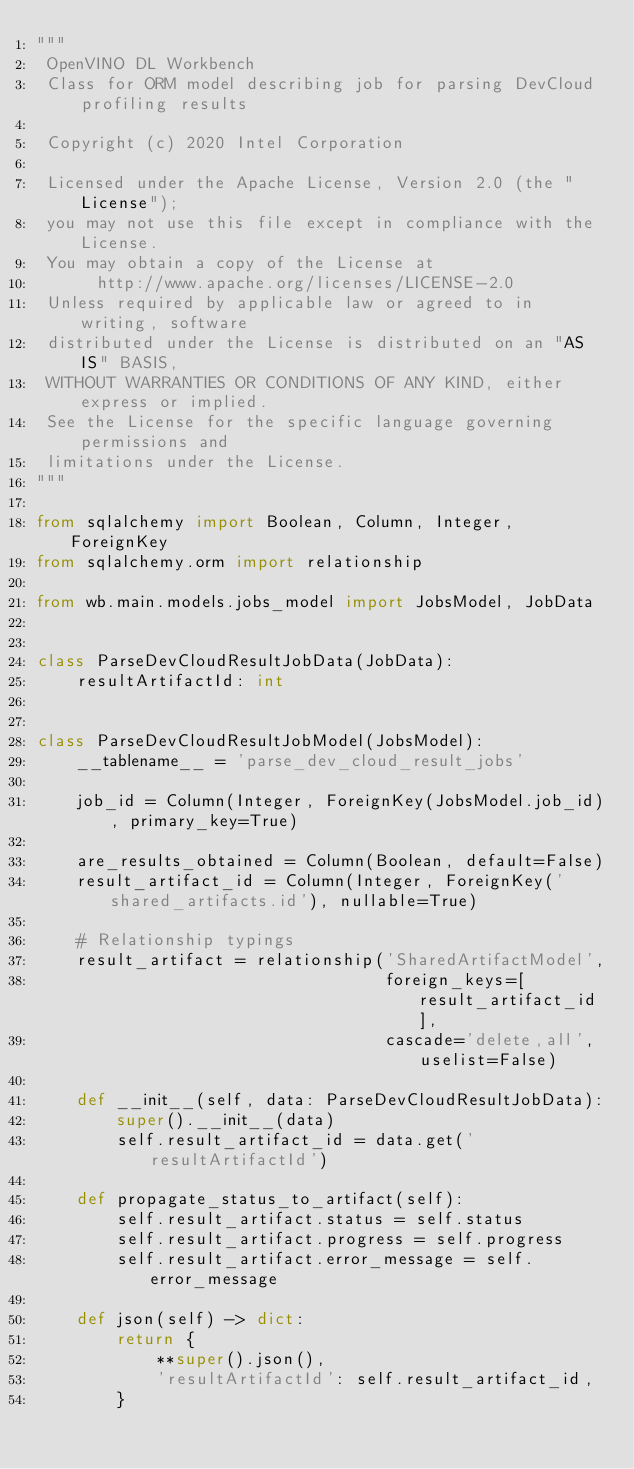Convert code to text. <code><loc_0><loc_0><loc_500><loc_500><_Python_>"""
 OpenVINO DL Workbench
 Class for ORM model describing job for parsing DevCloud profiling results

 Copyright (c) 2020 Intel Corporation

 Licensed under the Apache License, Version 2.0 (the "License");
 you may not use this file except in compliance with the License.
 You may obtain a copy of the License at
      http://www.apache.org/licenses/LICENSE-2.0
 Unless required by applicable law or agreed to in writing, software
 distributed under the License is distributed on an "AS IS" BASIS,
 WITHOUT WARRANTIES OR CONDITIONS OF ANY KIND, either express or implied.
 See the License for the specific language governing permissions and
 limitations under the License.
"""

from sqlalchemy import Boolean, Column, Integer, ForeignKey
from sqlalchemy.orm import relationship

from wb.main.models.jobs_model import JobsModel, JobData


class ParseDevCloudResultJobData(JobData):
    resultArtifactId: int


class ParseDevCloudResultJobModel(JobsModel):
    __tablename__ = 'parse_dev_cloud_result_jobs'

    job_id = Column(Integer, ForeignKey(JobsModel.job_id), primary_key=True)

    are_results_obtained = Column(Boolean, default=False)
    result_artifact_id = Column(Integer, ForeignKey('shared_artifacts.id'), nullable=True)

    # Relationship typings
    result_artifact = relationship('SharedArtifactModel',
                                   foreign_keys=[result_artifact_id],
                                   cascade='delete,all', uselist=False)

    def __init__(self, data: ParseDevCloudResultJobData):
        super().__init__(data)
        self.result_artifact_id = data.get('resultArtifactId')

    def propagate_status_to_artifact(self):
        self.result_artifact.status = self.status
        self.result_artifact.progress = self.progress
        self.result_artifact.error_message = self.error_message

    def json(self) -> dict:
        return {
            **super().json(),
            'resultArtifactId': self.result_artifact_id,
        }
</code> 